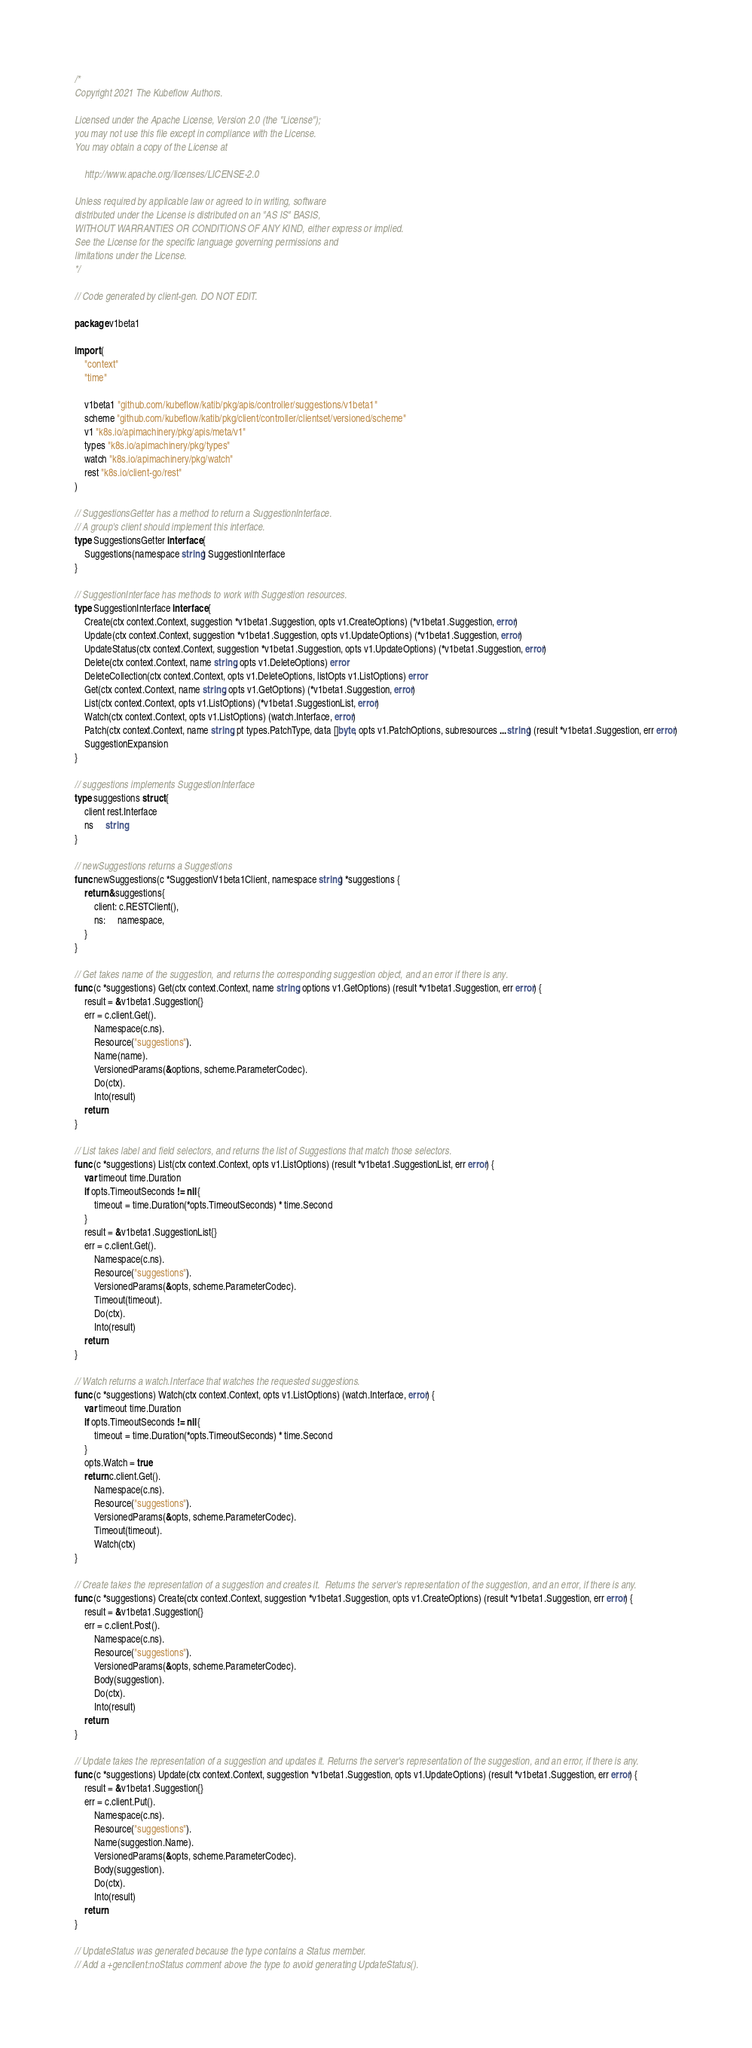<code> <loc_0><loc_0><loc_500><loc_500><_Go_>/*
Copyright 2021 The Kubeflow Authors.

Licensed under the Apache License, Version 2.0 (the "License");
you may not use this file except in compliance with the License.
You may obtain a copy of the License at

    http://www.apache.org/licenses/LICENSE-2.0

Unless required by applicable law or agreed to in writing, software
distributed under the License is distributed on an "AS IS" BASIS,
WITHOUT WARRANTIES OR CONDITIONS OF ANY KIND, either express or implied.
See the License for the specific language governing permissions and
limitations under the License.
*/

// Code generated by client-gen. DO NOT EDIT.

package v1beta1

import (
	"context"
	"time"

	v1beta1 "github.com/kubeflow/katib/pkg/apis/controller/suggestions/v1beta1"
	scheme "github.com/kubeflow/katib/pkg/client/controller/clientset/versioned/scheme"
	v1 "k8s.io/apimachinery/pkg/apis/meta/v1"
	types "k8s.io/apimachinery/pkg/types"
	watch "k8s.io/apimachinery/pkg/watch"
	rest "k8s.io/client-go/rest"
)

// SuggestionsGetter has a method to return a SuggestionInterface.
// A group's client should implement this interface.
type SuggestionsGetter interface {
	Suggestions(namespace string) SuggestionInterface
}

// SuggestionInterface has methods to work with Suggestion resources.
type SuggestionInterface interface {
	Create(ctx context.Context, suggestion *v1beta1.Suggestion, opts v1.CreateOptions) (*v1beta1.Suggestion, error)
	Update(ctx context.Context, suggestion *v1beta1.Suggestion, opts v1.UpdateOptions) (*v1beta1.Suggestion, error)
	UpdateStatus(ctx context.Context, suggestion *v1beta1.Suggestion, opts v1.UpdateOptions) (*v1beta1.Suggestion, error)
	Delete(ctx context.Context, name string, opts v1.DeleteOptions) error
	DeleteCollection(ctx context.Context, opts v1.DeleteOptions, listOpts v1.ListOptions) error
	Get(ctx context.Context, name string, opts v1.GetOptions) (*v1beta1.Suggestion, error)
	List(ctx context.Context, opts v1.ListOptions) (*v1beta1.SuggestionList, error)
	Watch(ctx context.Context, opts v1.ListOptions) (watch.Interface, error)
	Patch(ctx context.Context, name string, pt types.PatchType, data []byte, opts v1.PatchOptions, subresources ...string) (result *v1beta1.Suggestion, err error)
	SuggestionExpansion
}

// suggestions implements SuggestionInterface
type suggestions struct {
	client rest.Interface
	ns     string
}

// newSuggestions returns a Suggestions
func newSuggestions(c *SuggestionV1beta1Client, namespace string) *suggestions {
	return &suggestions{
		client: c.RESTClient(),
		ns:     namespace,
	}
}

// Get takes name of the suggestion, and returns the corresponding suggestion object, and an error if there is any.
func (c *suggestions) Get(ctx context.Context, name string, options v1.GetOptions) (result *v1beta1.Suggestion, err error) {
	result = &v1beta1.Suggestion{}
	err = c.client.Get().
		Namespace(c.ns).
		Resource("suggestions").
		Name(name).
		VersionedParams(&options, scheme.ParameterCodec).
		Do(ctx).
		Into(result)
	return
}

// List takes label and field selectors, and returns the list of Suggestions that match those selectors.
func (c *suggestions) List(ctx context.Context, opts v1.ListOptions) (result *v1beta1.SuggestionList, err error) {
	var timeout time.Duration
	if opts.TimeoutSeconds != nil {
		timeout = time.Duration(*opts.TimeoutSeconds) * time.Second
	}
	result = &v1beta1.SuggestionList{}
	err = c.client.Get().
		Namespace(c.ns).
		Resource("suggestions").
		VersionedParams(&opts, scheme.ParameterCodec).
		Timeout(timeout).
		Do(ctx).
		Into(result)
	return
}

// Watch returns a watch.Interface that watches the requested suggestions.
func (c *suggestions) Watch(ctx context.Context, opts v1.ListOptions) (watch.Interface, error) {
	var timeout time.Duration
	if opts.TimeoutSeconds != nil {
		timeout = time.Duration(*opts.TimeoutSeconds) * time.Second
	}
	opts.Watch = true
	return c.client.Get().
		Namespace(c.ns).
		Resource("suggestions").
		VersionedParams(&opts, scheme.ParameterCodec).
		Timeout(timeout).
		Watch(ctx)
}

// Create takes the representation of a suggestion and creates it.  Returns the server's representation of the suggestion, and an error, if there is any.
func (c *suggestions) Create(ctx context.Context, suggestion *v1beta1.Suggestion, opts v1.CreateOptions) (result *v1beta1.Suggestion, err error) {
	result = &v1beta1.Suggestion{}
	err = c.client.Post().
		Namespace(c.ns).
		Resource("suggestions").
		VersionedParams(&opts, scheme.ParameterCodec).
		Body(suggestion).
		Do(ctx).
		Into(result)
	return
}

// Update takes the representation of a suggestion and updates it. Returns the server's representation of the suggestion, and an error, if there is any.
func (c *suggestions) Update(ctx context.Context, suggestion *v1beta1.Suggestion, opts v1.UpdateOptions) (result *v1beta1.Suggestion, err error) {
	result = &v1beta1.Suggestion{}
	err = c.client.Put().
		Namespace(c.ns).
		Resource("suggestions").
		Name(suggestion.Name).
		VersionedParams(&opts, scheme.ParameterCodec).
		Body(suggestion).
		Do(ctx).
		Into(result)
	return
}

// UpdateStatus was generated because the type contains a Status member.
// Add a +genclient:noStatus comment above the type to avoid generating UpdateStatus().</code> 